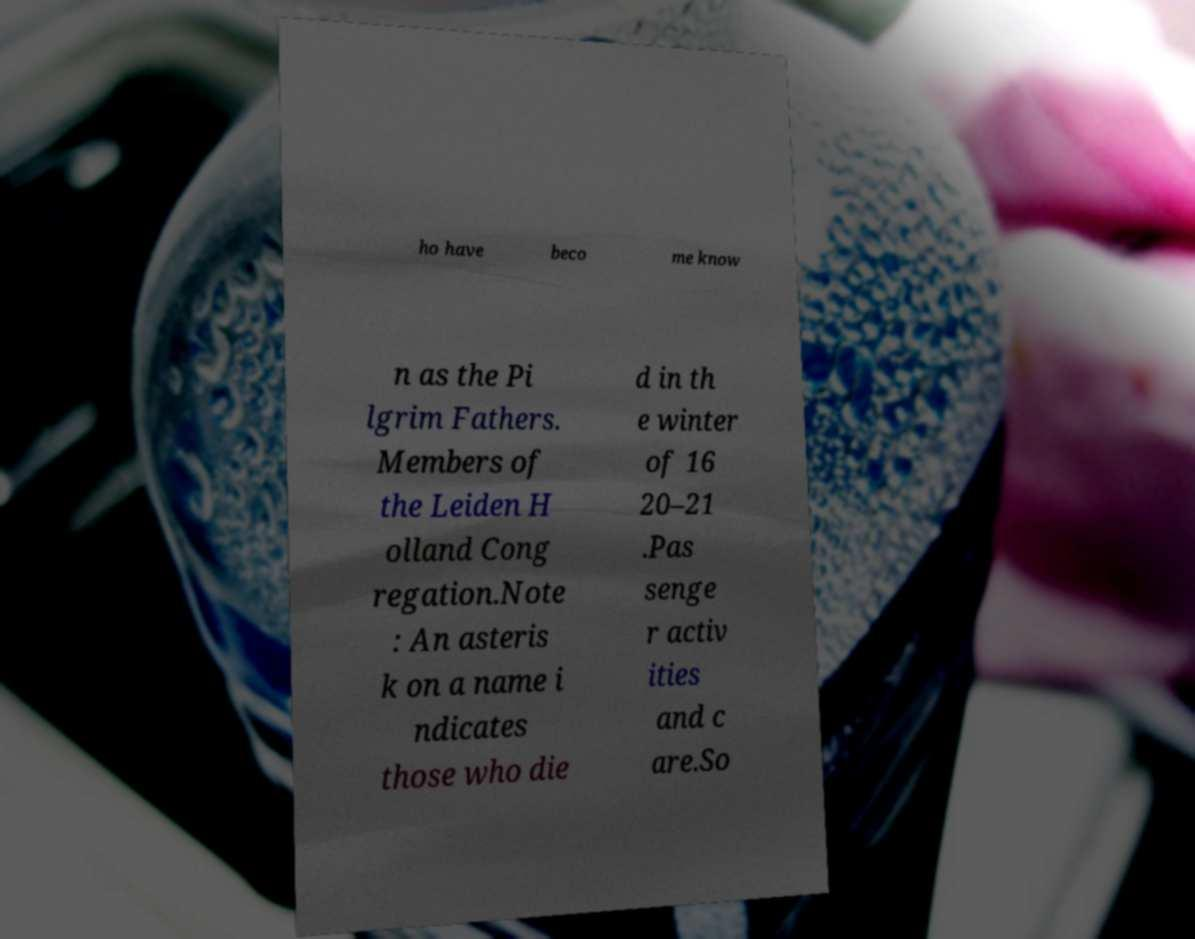Can you read and provide the text displayed in the image?This photo seems to have some interesting text. Can you extract and type it out for me? ho have beco me know n as the Pi lgrim Fathers. Members of the Leiden H olland Cong regation.Note : An asteris k on a name i ndicates those who die d in th e winter of 16 20–21 .Pas senge r activ ities and c are.So 